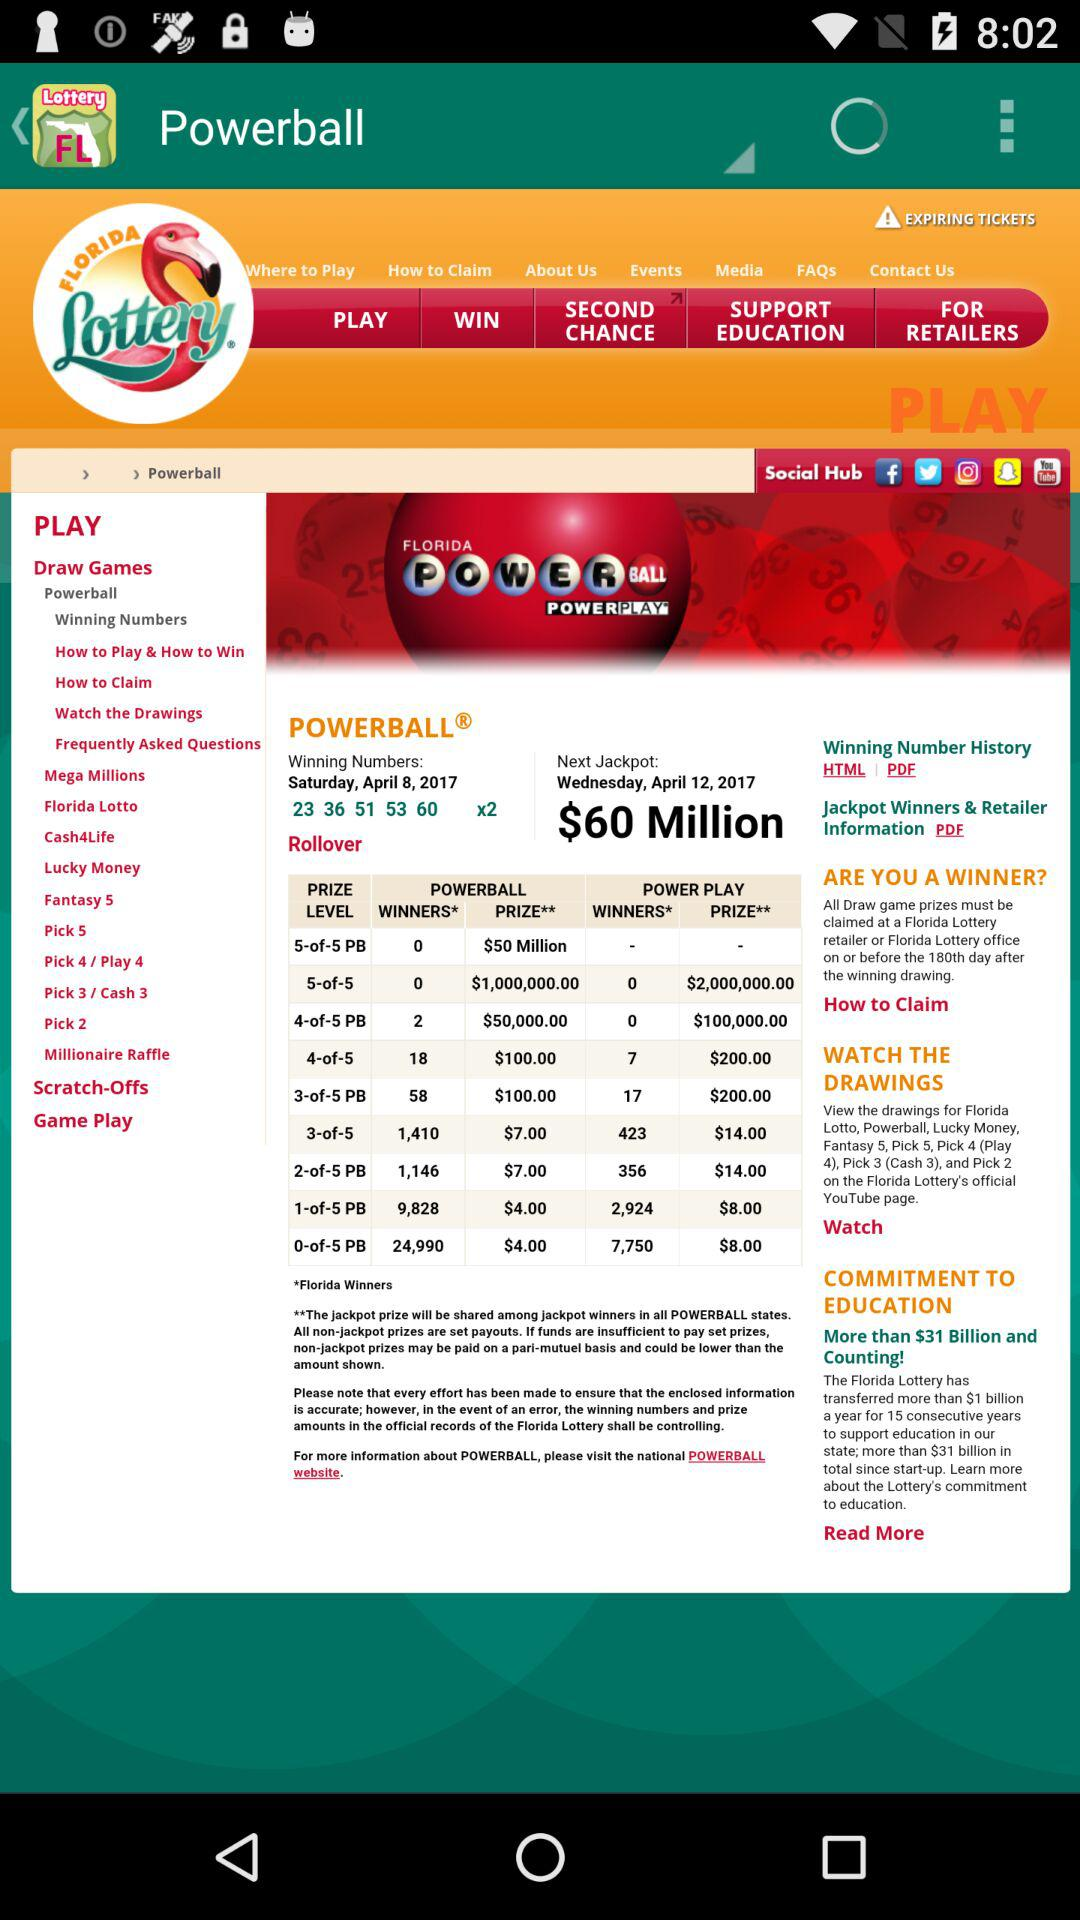What is the name of the lottery jackpot? The name of the lottery jackpot is "Powerball". 